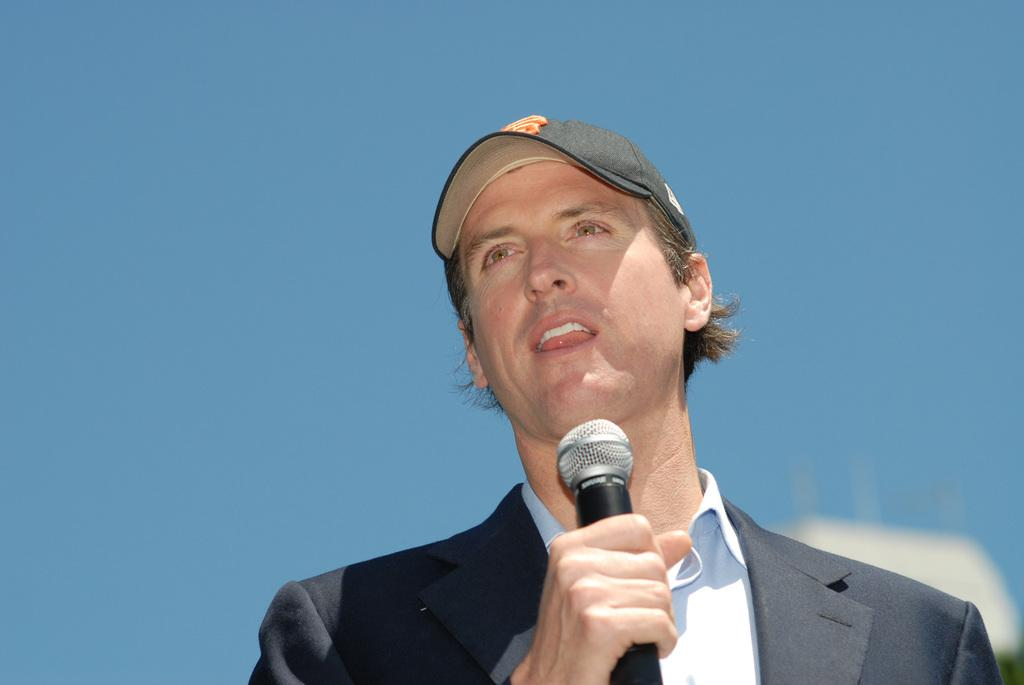What is the person in the image doing? The person is holding a microphone and talking. What is the person wearing? The person is wearing a black suit and a black cap. What can be seen at the top of the image? The sky is visible at the top of the image. How many screws are visible on the person's account in the image? There are no screws or accounts visible in the image; it features a person holding a microphone and talking. 